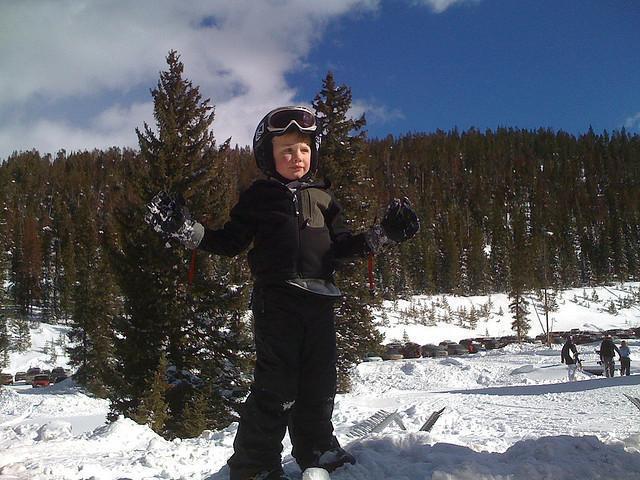How many people are in the photo?
Give a very brief answer. 4. How many numbers are on the clock tower?
Give a very brief answer. 0. 